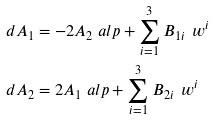<formula> <loc_0><loc_0><loc_500><loc_500>d A _ { 1 } & = - 2 A _ { 2 } \ a l p + \sum _ { i = 1 } ^ { 3 } B _ { 1 i } \, \ w ^ { i } \\ d A _ { 2 } & = 2 A _ { 1 } \ a l p + \sum _ { i = 1 } ^ { 3 } B _ { 2 i } \, \ w ^ { i }</formula> 